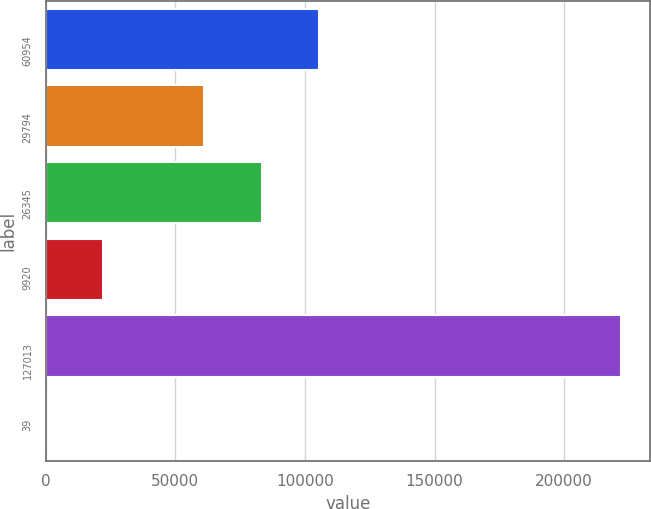Convert chart to OTSL. <chart><loc_0><loc_0><loc_500><loc_500><bar_chart><fcel>60954<fcel>29794<fcel>26345<fcel>9920<fcel>127013<fcel>39<nl><fcel>105488<fcel>61078<fcel>83283.1<fcel>22273.1<fcel>222119<fcel>68<nl></chart> 